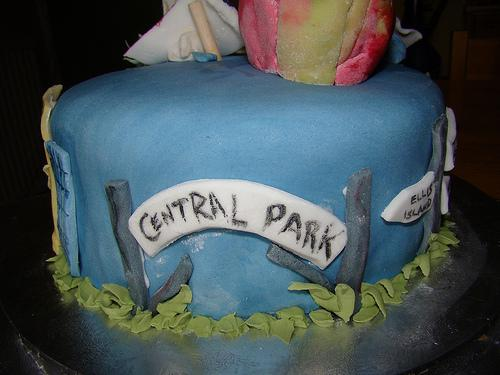What type of surface is the cake placed on, according to the information provided? The cake is placed on a wooden table over a metal tray. Identify the main colors featured on the cake in the image. The cake features colors such as blue, green, white, red, and yellow on its decorations and frosting. For the product advertisement task, briefly describe the unique design features of this cake. This eye-catching cake features a primarily blue design with intricate decorations like grass-shaped frosting, fondant leaves, and signs for Central Park and Ellis Island. For the referential expression grounding task, identify the color and text of one of the signs on the cake. One of the signs is white with black text reading "Ellis Island." Based on the captions, describe the decorative elements on the cake's base. The base of the cake has green grass-shaped frosting and green fondant leaves as decorations. In a few words, describe the content of the writing on the cake. The cake has a sign reading "Central Park" and another sign for "Ellis Island." In the context of the referential expression grounding task, identify an object in the background. There is a wooden chair in the background. In the multi-choice VQA task, choose the main color of the cake: red, green, blue, or yellow. The main color of the cake is blue. For the visual entailment task, list some objects or elements mentioned in the given image captions. Objects include a frosting sign, white cloth, blue fondant rectangle, green fondant leaves, wooden stick, and a silver platter. For the visual entailment task, describe the overall theme of the cake based on the frosting and decorations. The cake seems to have a nature and landmarks theme, incorporating grass, leaves, and signs for Central Park and Ellis Island. 